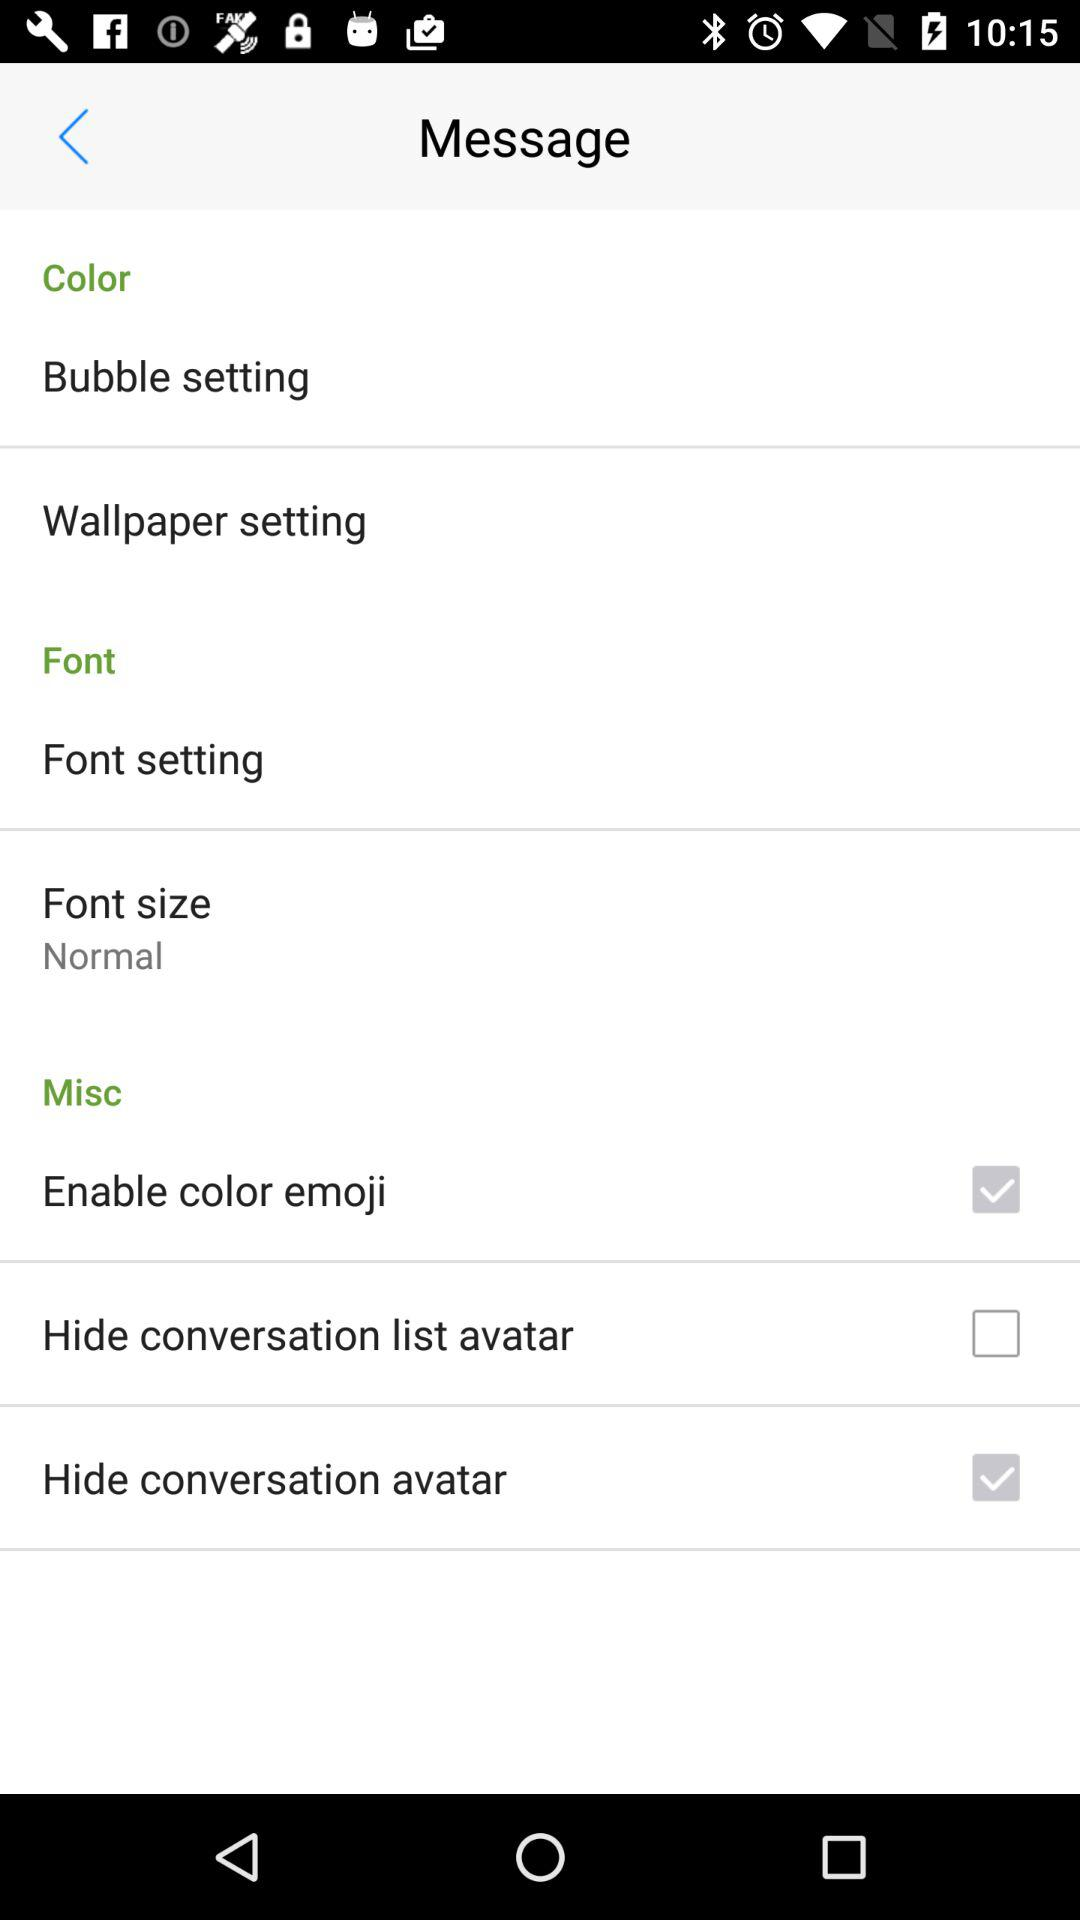What is the status of "Hide conversation list avatar"? The status of "Hide conversation list avatar" is "off". 